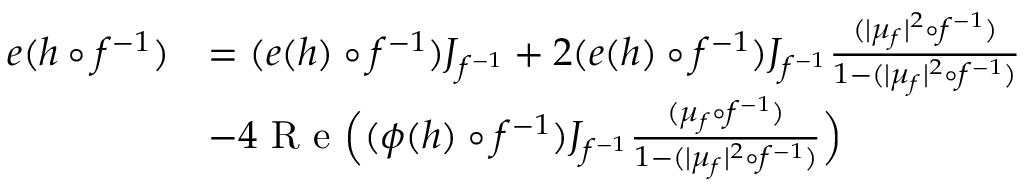<formula> <loc_0><loc_0><loc_500><loc_500>\begin{array} { r l } { e ( h \circ f ^ { - 1 } ) } & { = ( e ( h ) \circ f ^ { - 1 } ) J _ { f ^ { - 1 } } + 2 ( e ( h ) \circ f ^ { - 1 } ) J _ { f ^ { - 1 } } \frac { ( | \mu _ { f } | ^ { 2 } \circ f ^ { - 1 } ) } { 1 - ( | \mu _ { f } | ^ { 2 } \circ f ^ { - 1 } ) } } \\ & { - 4 R e \left ( ( \phi ( h ) \circ f ^ { - 1 } ) J _ { f ^ { - 1 } } \frac { ( \mu _ { f } \circ f ^ { - 1 } ) } { 1 - ( | \mu _ { f } | ^ { 2 } \circ f ^ { - 1 } ) } \right ) } \end{array}</formula> 